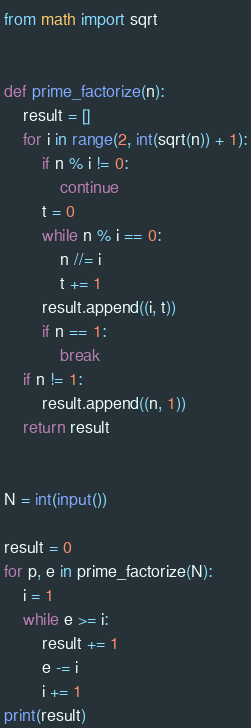Convert code to text. <code><loc_0><loc_0><loc_500><loc_500><_Python_>from math import sqrt


def prime_factorize(n):
    result = []
    for i in range(2, int(sqrt(n)) + 1):
        if n % i != 0:
            continue
        t = 0
        while n % i == 0:
            n //= i
            t += 1
        result.append((i, t))
        if n == 1:
            break
    if n != 1:
        result.append((n, 1))
    return result


N = int(input())

result = 0
for p, e in prime_factorize(N):
    i = 1
    while e >= i:
        result += 1
        e -= i
        i += 1
print(result)
</code> 